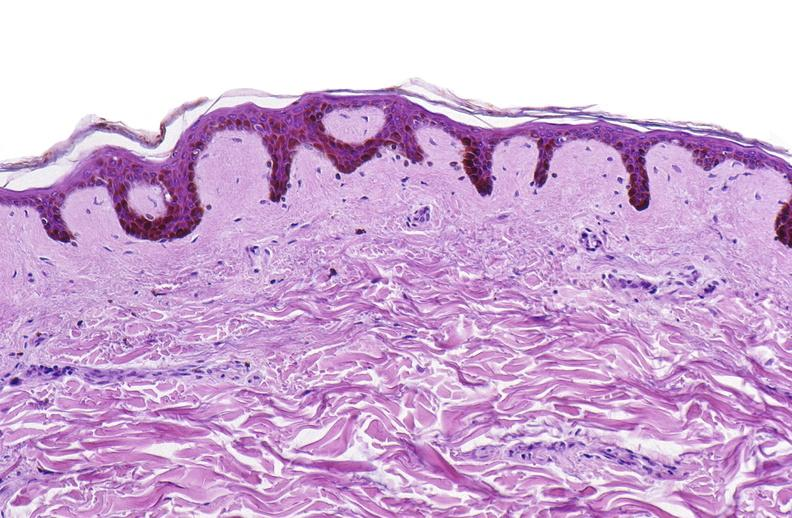does this image show scleroderma?
Answer the question using a single word or phrase. Yes 